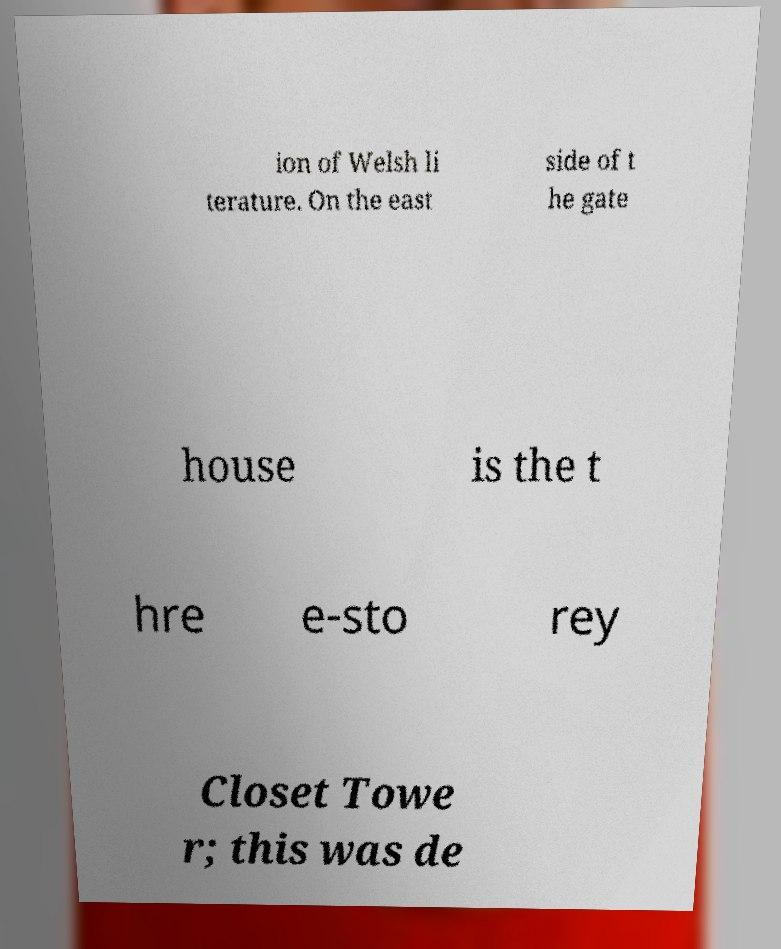Please read and relay the text visible in this image. What does it say? ion of Welsh li terature. On the east side of t he gate house is the t hre e-sto rey Closet Towe r; this was de 